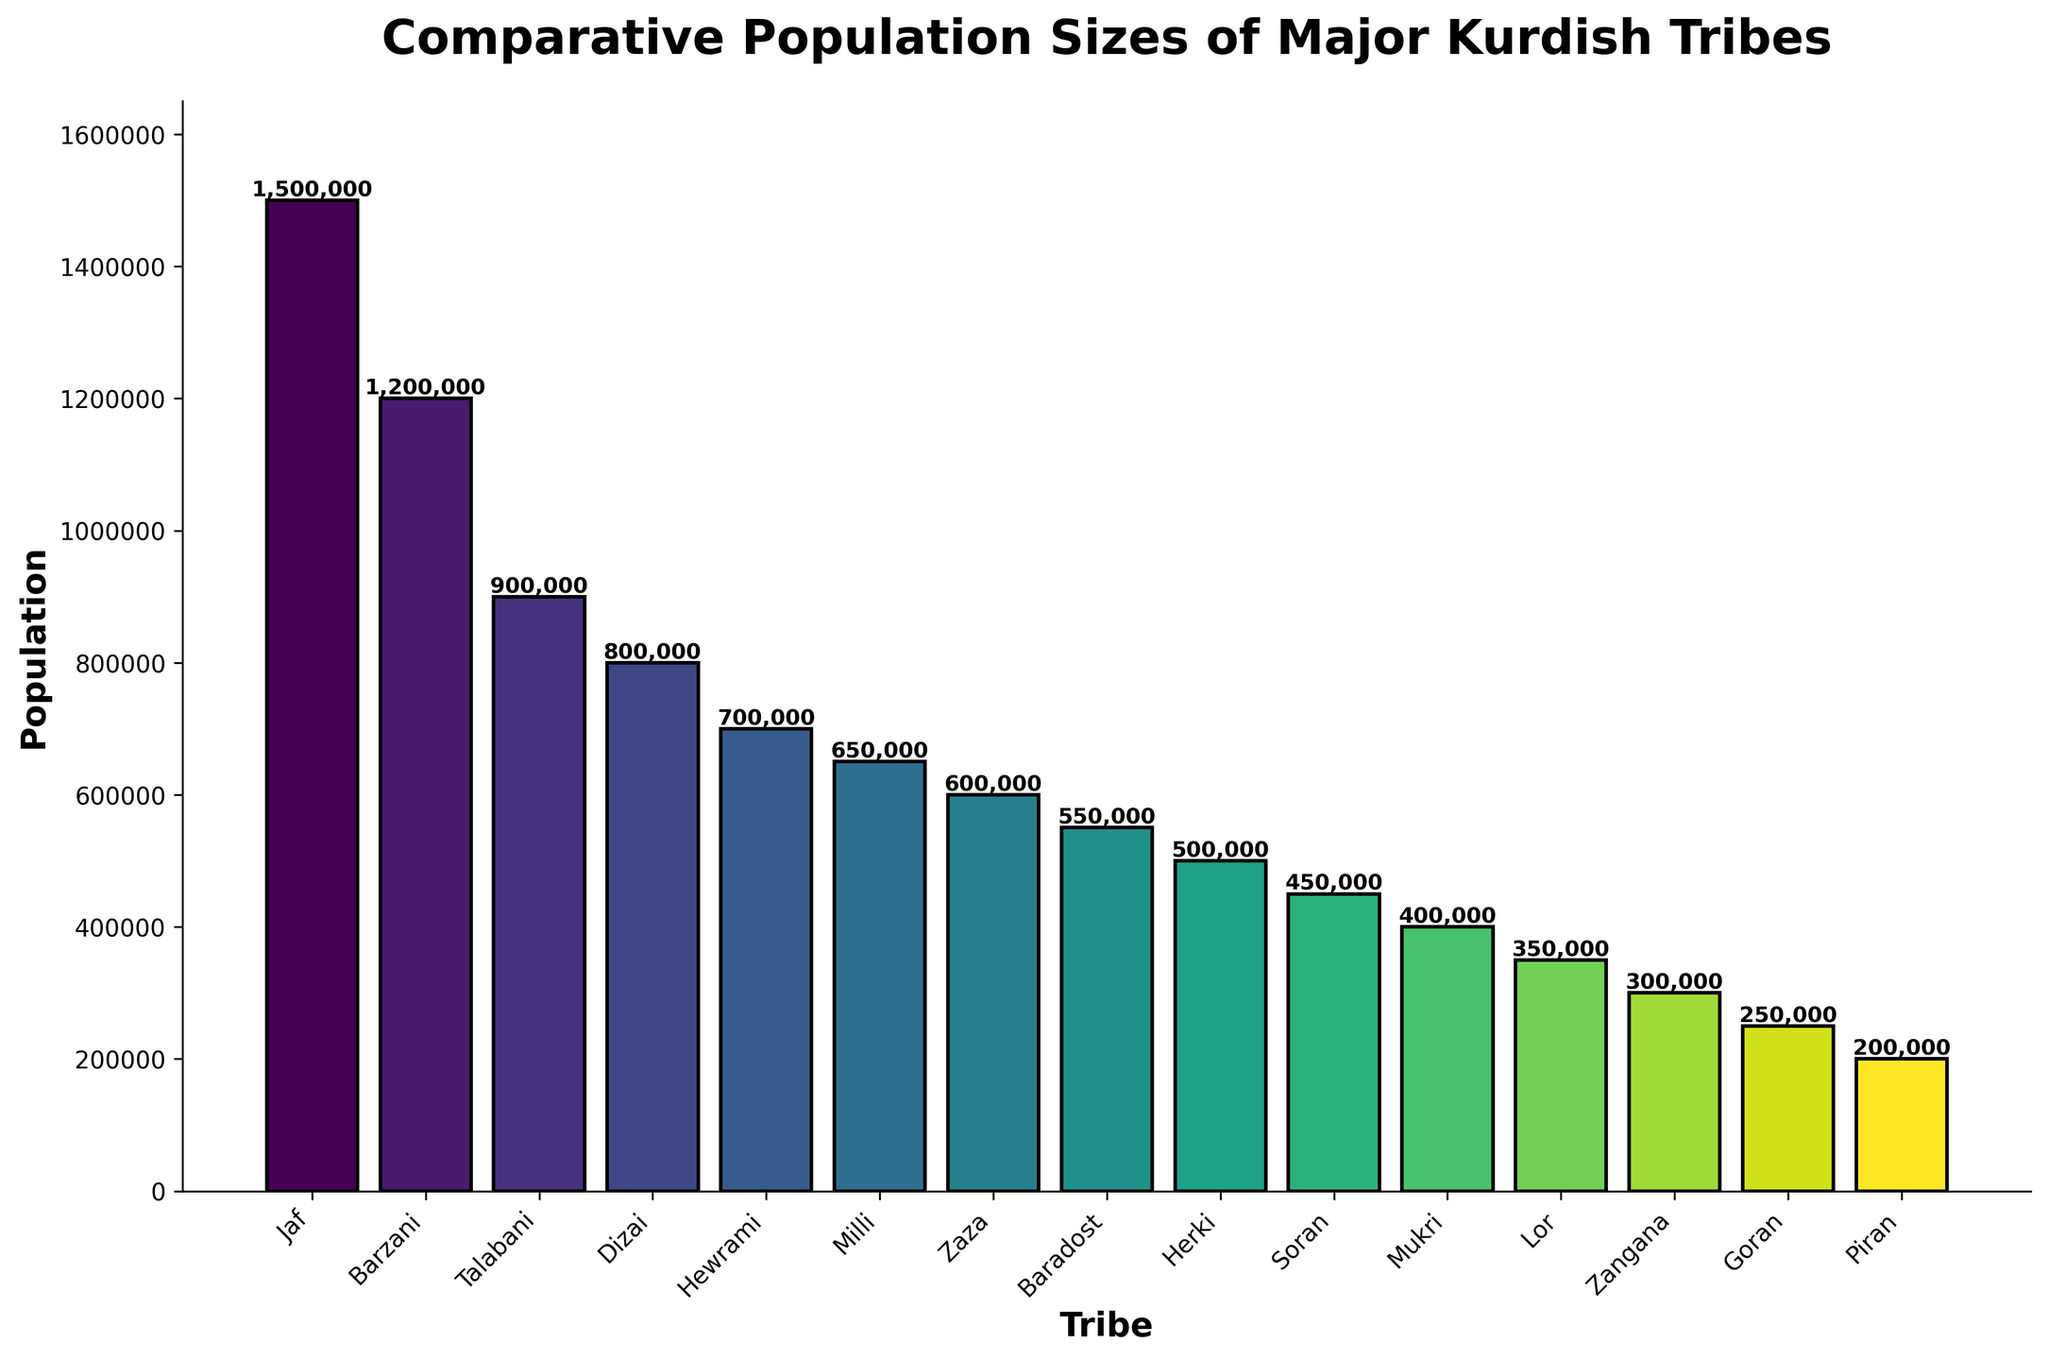Which tribe has the highest population? By looking at the heights of the bars, the 'Jaf' tribe has the tallest bar, indicating it has the highest population.
Answer: Jaf Which tribe has the lowest population? By observing the heights of the bars, the 'Piran' tribe has the shortest bar, indicating it has the lowest population.
Answer: Piran What is the combined population of the Barzani and Talabani tribes? The population of the Barzani tribe is 1,200,000 and the Talabani tribe is 900,000. Adding them together: 1,200,000 + 900,000 = 2,100,000.
Answer: 2,100,000 How many tribes have a population greater than 1,000,000? By counting the tribes with bars that extend beyond the 1,000,000 mark on the y-axis, we see there are 2 tribes: Jaf and Barzani.
Answer: 2 What is the average population size of all tribes shown? Adding all tribe populations: 1,500,000 (Jaf) + 1,200,000 (Barzani) + 900,000 (Talabani) + 800,000 (Dizai) + 700,000 (Hewrami) + 650,000 (Milli) + 600,000 (Zaza) + 550,000 (Baradost) + 500,000 (Herki) + 450,000 (Soran) + 400,000 (Mukri) + 350,000 (Lor) + 300,000 (Zangana) + 250,000 (Goran) + 200,000 (Piran) = 9,850,000. Dividing by the number of tribes (15) gives: 9,850,000 / 15 = 656,667.
Answer: 656,667 What's the difference in population size between the Herki and Soran tribes? The population of the Herki tribe is 500,000 and the Soran tribe is 450,000. The difference is: 500,000 - 450,000 = 50,000.
Answer: 50,000 Which tribe has a larger population, Goran or Mukri? By comparing the heights of their bars, the Mukri tribe has a taller bar than the Goran tribe. Therefore, the Mukri tribe has a larger population.
Answer: Mukri What is the median population size of the tribes? To find the median, list the populations in ascending order: 200,000, 250,000, 300,000, 350,000, 400,000, 450,000, 500,000, 550,000, 600,000, 650,000, 700,000, 800,000, 900,000, 1,200,000, 1,500,000. The median is the middle value. Here, the eighth value is the middle one in the sorted list, which is 550,000.
Answer: 550,000 Which two tribes have the closest population sizes? The populations of the Herki (500,000) and Soran (450,000) tribes are closest to each other, with only a 50,000 difference.
Answer: Herki and Soran Are there more tribes with populations above or below 500,000? Counting the tribes with populations above 500,000 (7) and below 500,000 (8), there are more tribes with populations below 500,000.
Answer: Below Describe the visual cue that distinguishes the tribe with the highest population. The Jaf tribe has the highest population, marked by the tallest and positionally leftmost bar in the plot, indicating its prominence among the major Kurdish tribes.
Answer: Tallest bar 